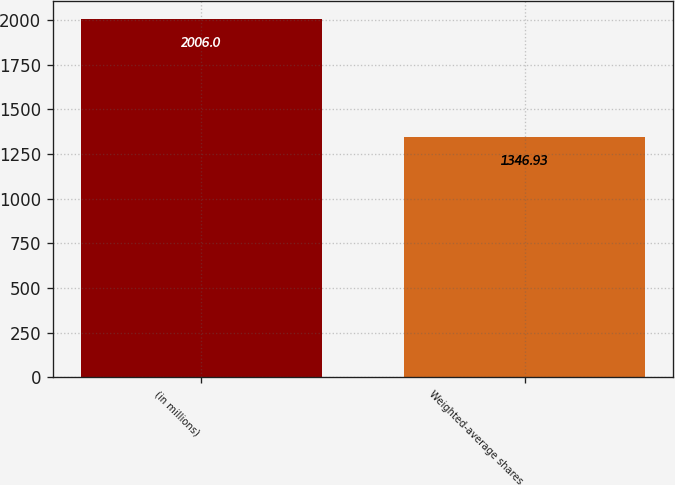<chart> <loc_0><loc_0><loc_500><loc_500><bar_chart><fcel>(in millions)<fcel>Weighted-average shares<nl><fcel>2006<fcel>1346.93<nl></chart> 